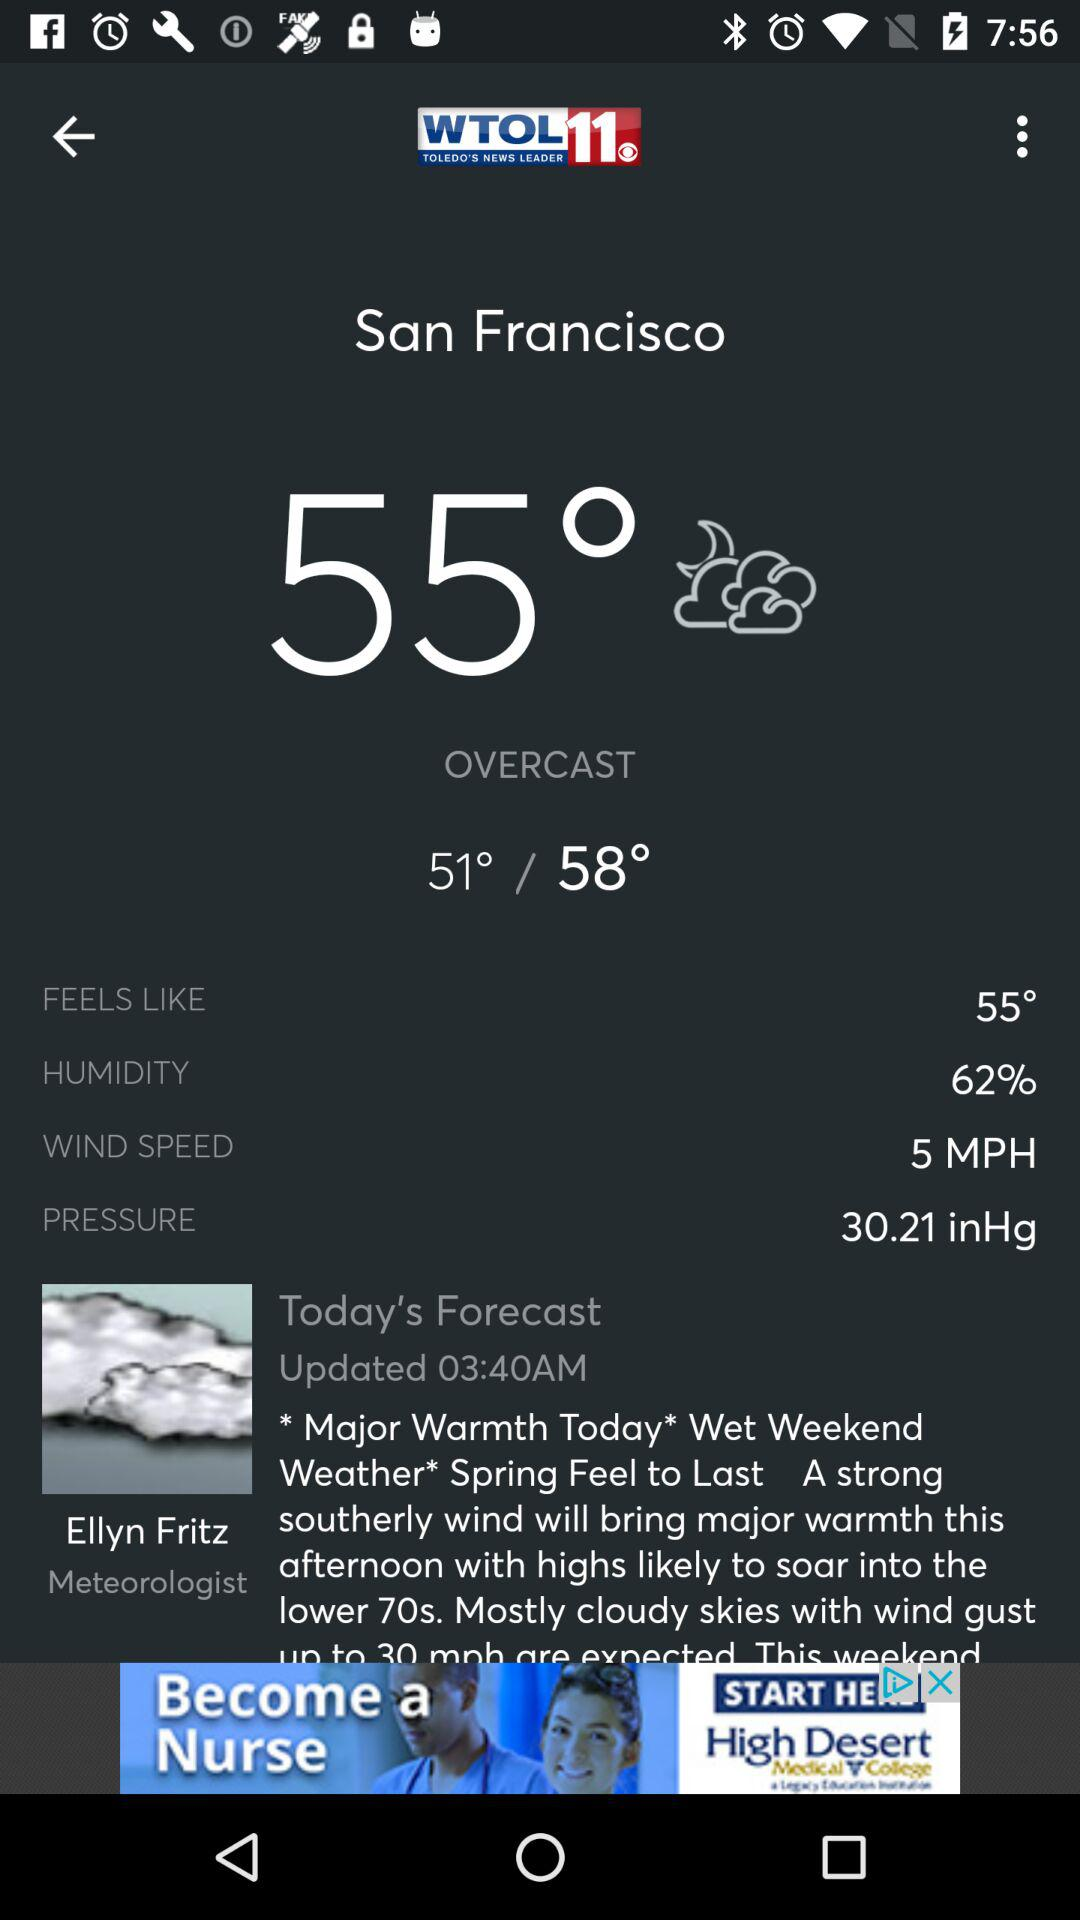What is the wind speed in miles per hour?
Answer the question using a single word or phrase. 5 MPH 